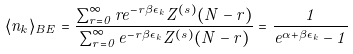<formula> <loc_0><loc_0><loc_500><loc_500>\langle n _ { k } \rangle _ { B E } = \frac { \sum _ { r = 0 } ^ { \infty } r e ^ { - r \beta \epsilon _ { k } } Z ^ { ( s ) } ( N - r ) } { \sum _ { r = 0 } ^ { \infty } e ^ { - r \beta \epsilon _ { k } } Z ^ { ( s ) } ( N - r ) } = \frac { 1 } { e ^ { \alpha + \beta \epsilon _ { k } } - 1 }</formula> 